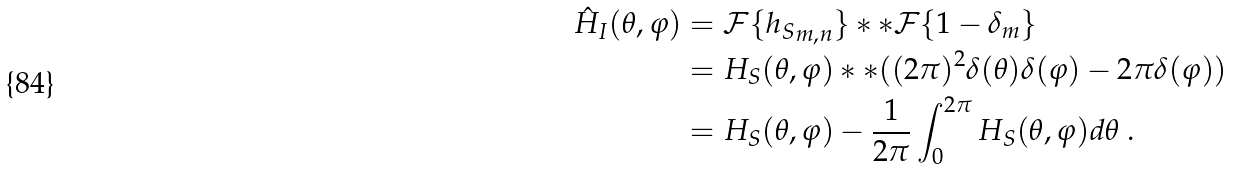<formula> <loc_0><loc_0><loc_500><loc_500>\hat { H } _ { I } ( \theta , \varphi ) & = \mathcal { F } \{ { h _ { S } } _ { m , n } \} \ast \ast \mathcal { F } \{ 1 - \delta _ { m } \} \\ & = H _ { S } ( \theta , \varphi ) \ast \ast ( ( 2 \pi ) ^ { 2 } \delta ( \theta ) \delta ( \varphi ) - 2 \pi \delta ( \varphi ) ) \\ & = H _ { S } ( \theta , \varphi ) - \frac { 1 } { 2 \pi } \int _ { 0 } ^ { 2 \pi } H _ { S } ( \theta , \varphi ) d \theta \ .</formula> 